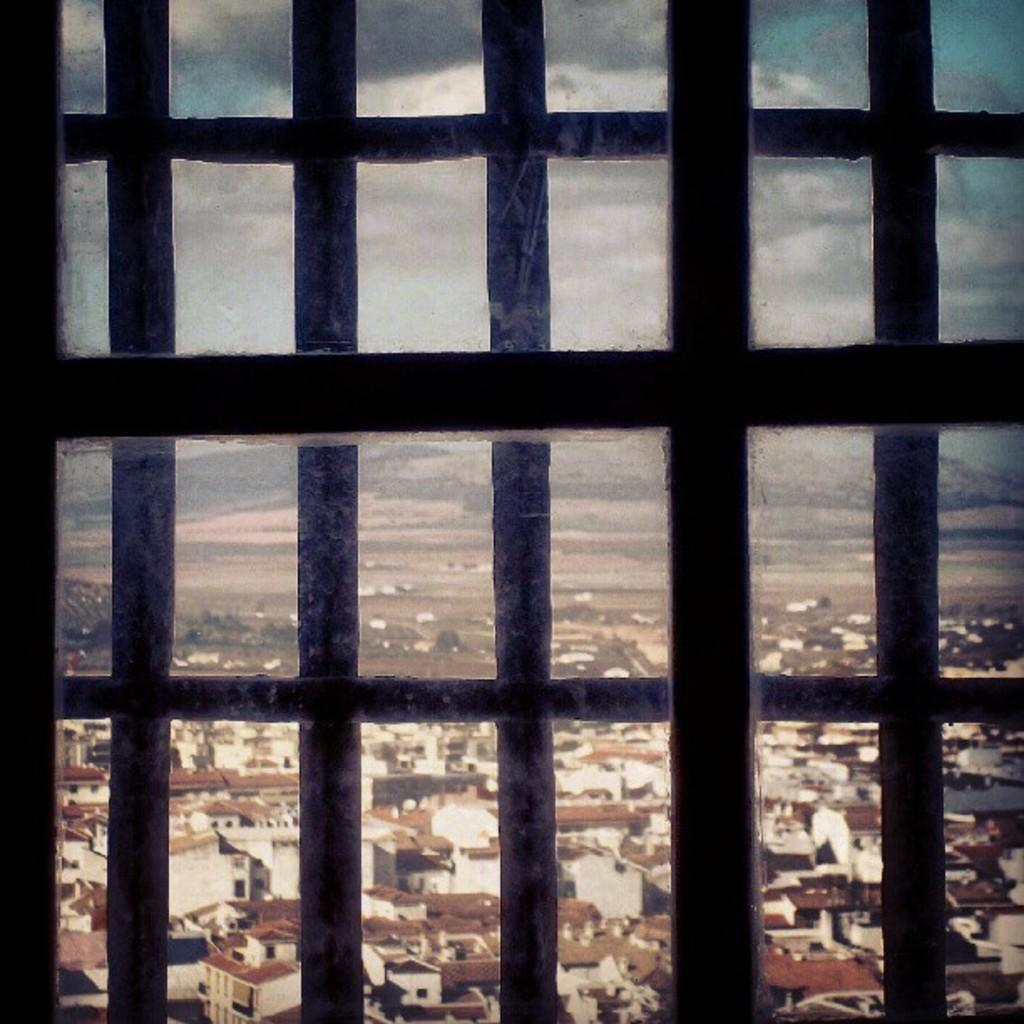What is located in the foreground of the image? There is a window in the foreground of the image. What can be seen through the window? Houses, buildings, the sky, trees, and other objects are visible through the window. Can you describe the view through the window? The view includes houses, buildings, the sky, trees, and other objects. What type of guitar is being played by the organization in the image? There is no guitar or organization present in the image; it only features a window with a view of houses, buildings, the sky, trees, and other objects. 